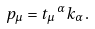Convert formula to latex. <formula><loc_0><loc_0><loc_500><loc_500>p _ { \mu } = t _ { \mu } \, ^ { \alpha } k _ { \alpha } \, .</formula> 